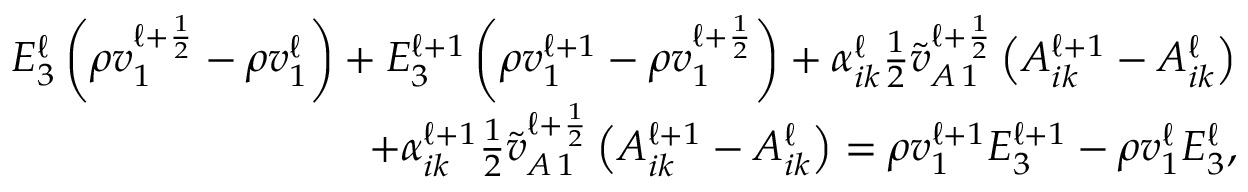<formula> <loc_0><loc_0><loc_500><loc_500>\begin{array} { r } { E _ { 3 } ^ { \ell } \left ( \rho v _ { 1 } ^ { \ell + \frac { 1 } { 2 } } - \rho v _ { 1 } ^ { \ell } \right ) + E _ { 3 } ^ { \ell + 1 } \left ( \rho v _ { 1 } ^ { \ell + 1 } - \rho v _ { 1 } ^ { \ell + \frac { 1 } { 2 } } \right ) + \alpha _ { i k } ^ { \ell } \frac { 1 } { 2 } \tilde { v } _ { A \, 1 } ^ { \ell + \frac { 1 } { 2 } } \left ( A _ { i k } ^ { \ell + 1 } - A _ { i k } ^ { \ell } \right ) } \\ { + \alpha _ { i k } ^ { \ell + 1 } \frac { 1 } { 2 } \tilde { v } _ { A \, 1 } ^ { \ell + \frac { 1 } { 2 } } \left ( A _ { i k } ^ { \ell + 1 } - A _ { i k } ^ { \ell } \right ) = \rho v _ { 1 } ^ { \ell + 1 } E _ { 3 } ^ { \ell + 1 } - \rho v _ { 1 } ^ { \ell } E _ { 3 } ^ { \ell } , } \end{array}</formula> 